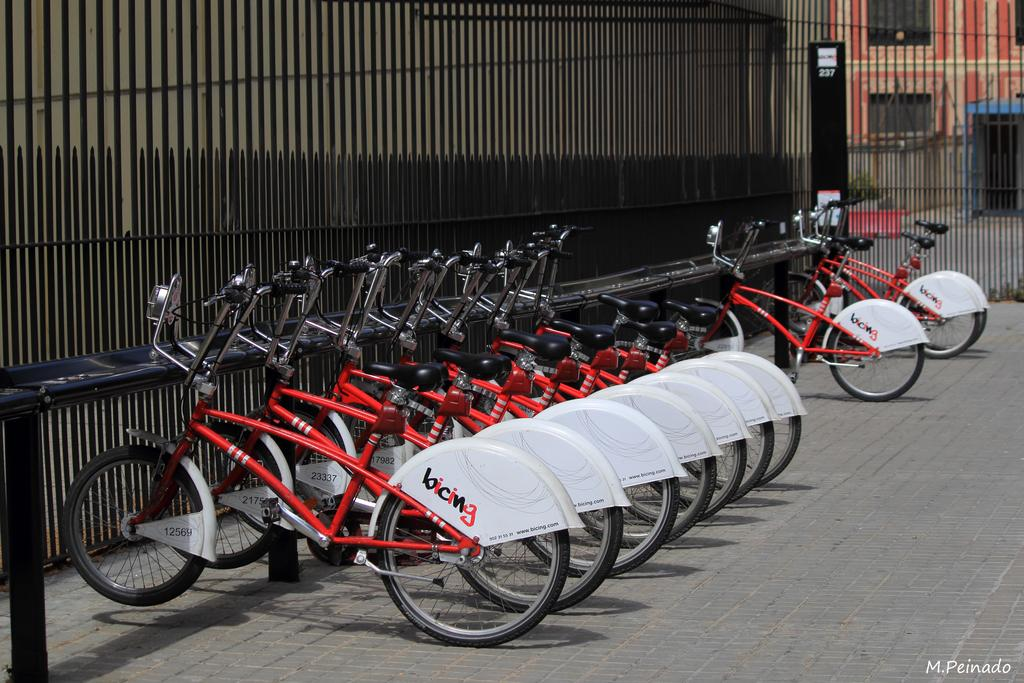What color are the bicycles in the image? The bicycles in the image are red. What is the state of the bicycles in the image? The bicycles are parked. What other object can be seen in the image? There is a black color grille in the image. What type of structure is visible in the image? There is a building in the image. Can you tell me which eye the mother is using to argue with the bicycle owner in the image? There is no mother or argument present in the image; it only features red color bicycles, a black color grille, and a building. 